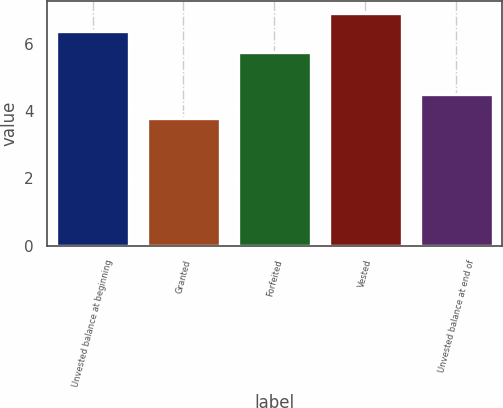Convert chart. <chart><loc_0><loc_0><loc_500><loc_500><bar_chart><fcel>Unvested balance at beginning<fcel>Granted<fcel>Forfeited<fcel>Vested<fcel>Unvested balance at end of<nl><fcel>6.41<fcel>3.81<fcel>5.76<fcel>6.93<fcel>4.52<nl></chart> 